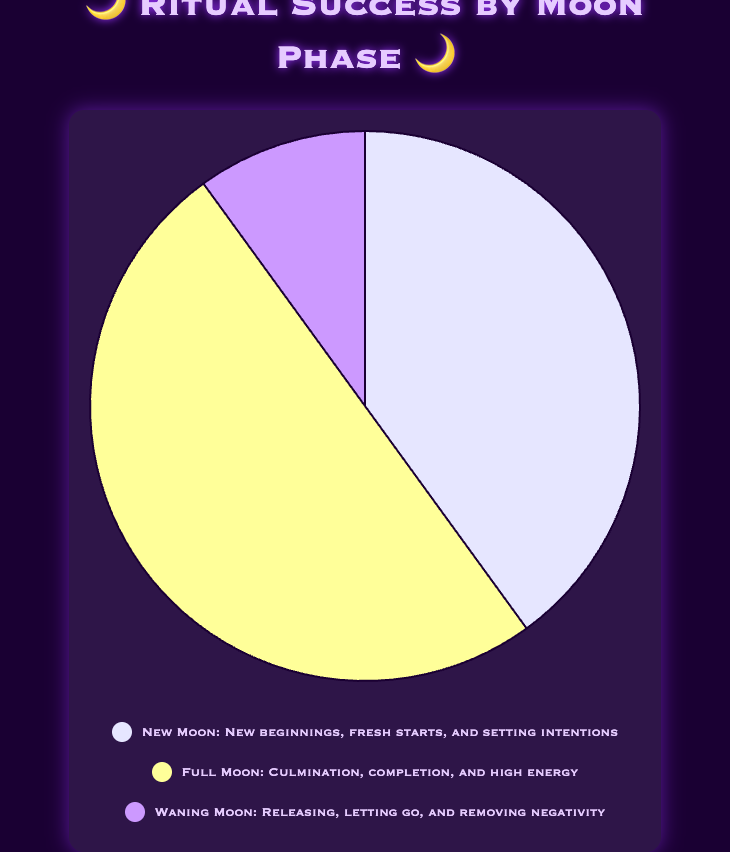What is the success rate during the Full Moon phase? The Full Moon slice of the pie chart has a label indicating a 50% success rate, represented by a yellow color.
Answer: 50% Which moon phase has the lowest success rate? Observing the pie chart, the Waning Moon slice is the smallest, indicating its success rate is the lowest at 10%.
Answer: Waning Moon How much greater is the success rate during the New Moon compared to the Waning Moon? The success rate for the New Moon is 40% and for the Waning Moon is 10%. Subtracting the success rate of the Waning Moon from the New Moon, we get 40% - 10% = 30%.
Answer: 30% What is the combined success rate of the New Moon and Waning Moon phases? Adding the success rates of the New Moon (40%) and Waning Moon (10%), we get 40% + 10% = 50%.
Answer: 50% Which moon phase is visually represented by the purple color in the chart? The pie chart indicates the purple segment corresponds to the Waning Moon.
Answer: Waning Moon Compare the sizes of the New Moon and Full Moon segments in the chart. Which is larger? Checking the slices in the pie chart, the Full Moon segment is larger than the New Moon, indicated by a bigger portion of the pie.
Answer: Full Moon What is the difference in success rates between the Full Moon and New Moon? The Full Moon has a 50% success rate, and the New Moon has a 40% success rate. The difference is 50% - 40% = 10%.
Answer: 10% What is the average success rate across all three moon phases? Adding the success rates of New Moon (40%), Full Moon (50%), and Waning Moon (10%), we get 40 + 50 + 10 = 100. Dividing by the number of phases (3), we get 100 / 3 ≈ 33.33%.
Answer: 33.33% If you combine the success rates of the waning and full moon phases, what percentage of the total does that represent? The combined success rate of the Waning Moon (10%) and Full Moon (50%) is 10 + 50 = 60%. The total success rate is 100%, so combining these phases represents 60% of the total.
Answer: 60% What is the purpose of rituals conducted during the New Moon based on the chart's legends? According to the legend, rituals during the New Moon focus on new beginnings, fresh starts, and setting intentions.
Answer: New beginnings, fresh starts, and setting intentions 